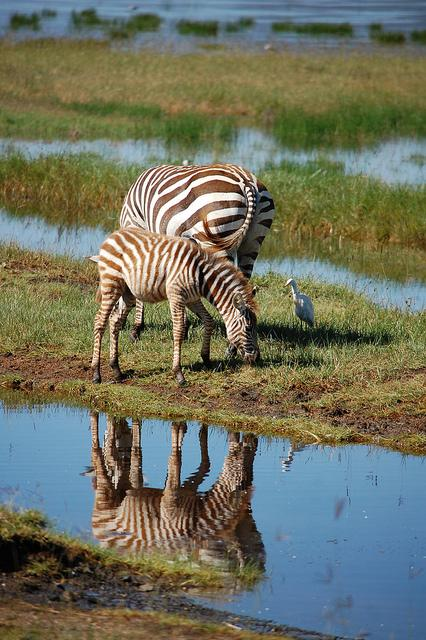Which animal is in danger from the other here?

Choices:
A) bird
B) reflection
C) neither
D) zebra neither 